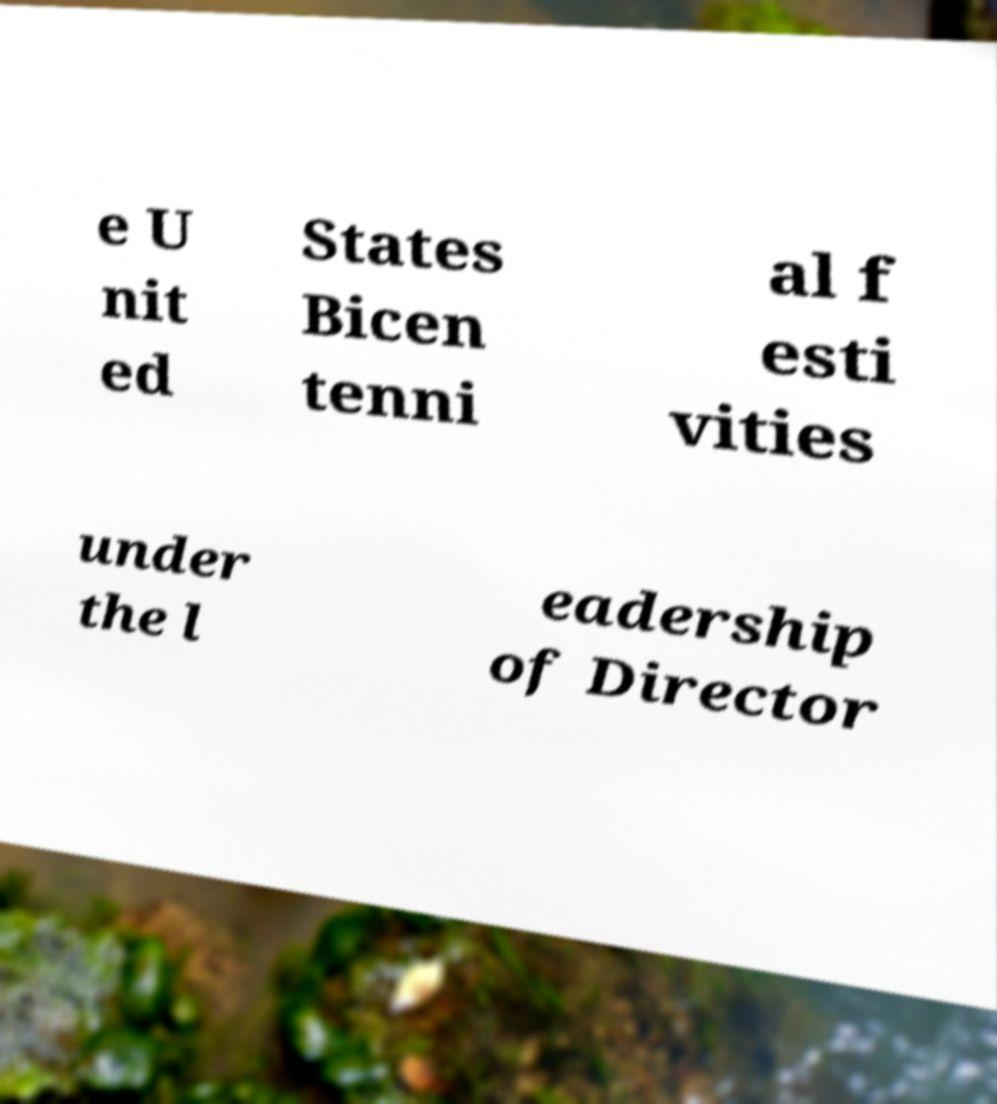For documentation purposes, I need the text within this image transcribed. Could you provide that? e U nit ed States Bicen tenni al f esti vities under the l eadership of Director 